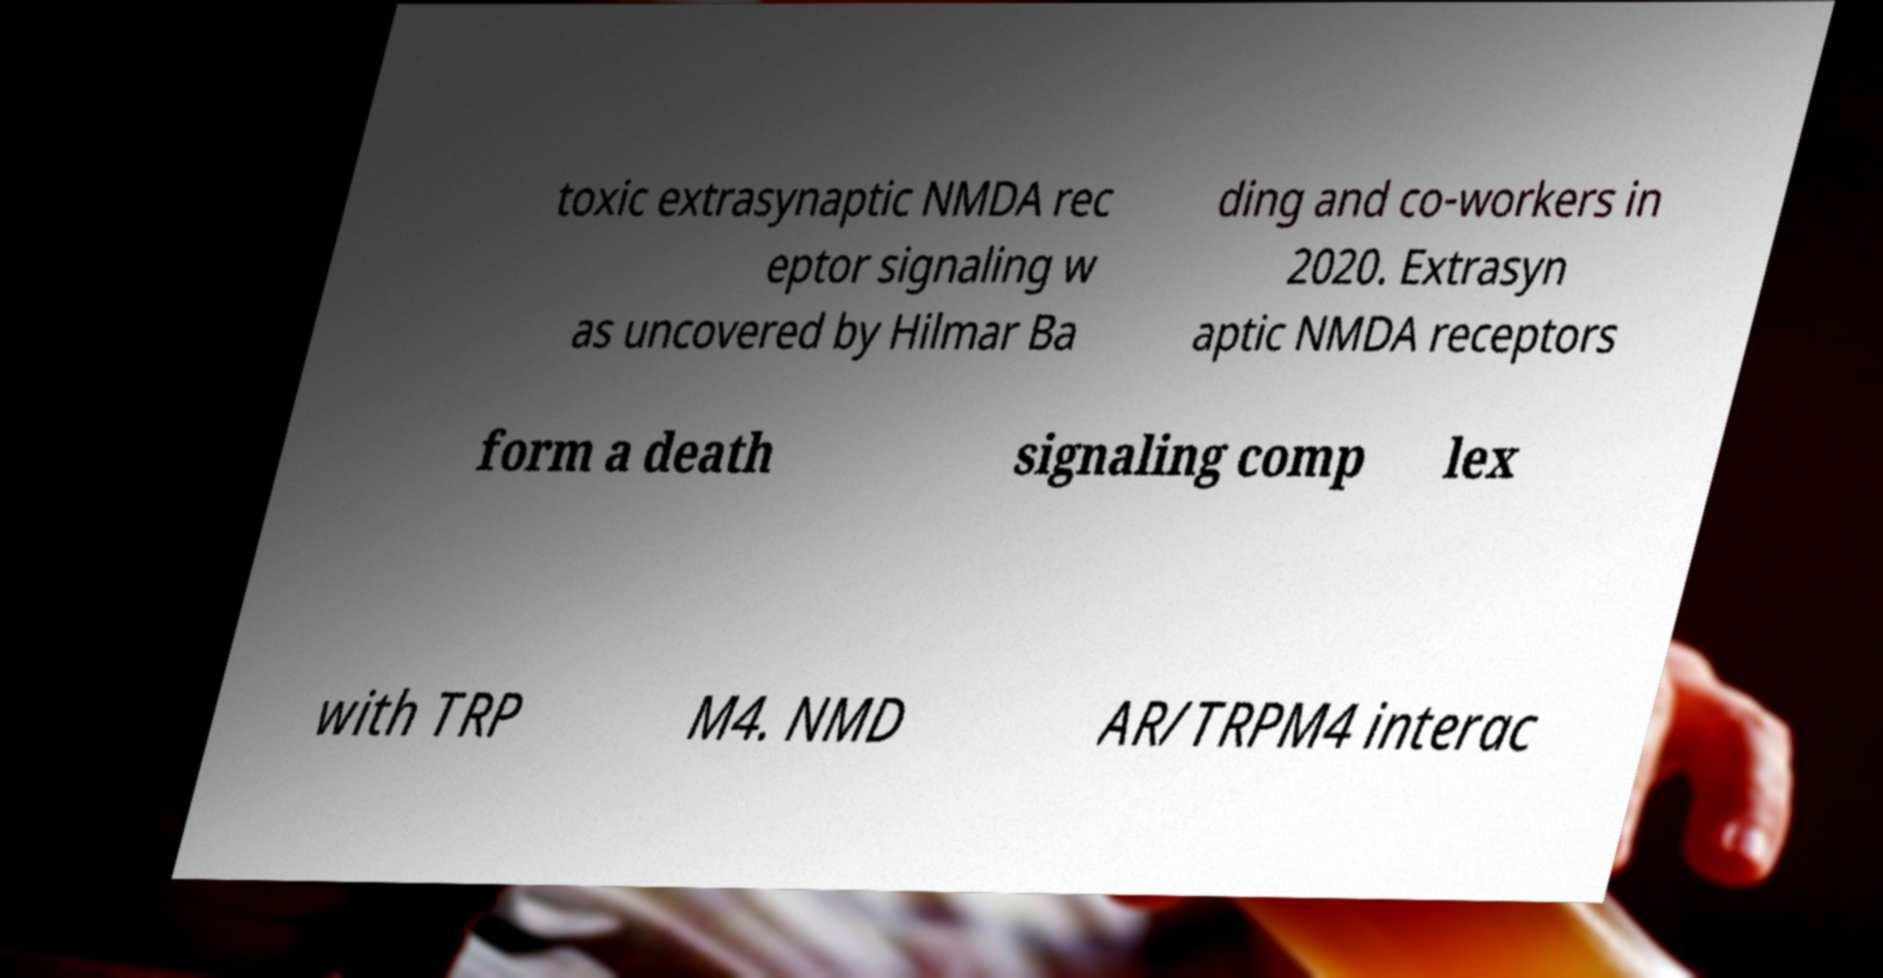Could you assist in decoding the text presented in this image and type it out clearly? toxic extrasynaptic NMDA rec eptor signaling w as uncovered by Hilmar Ba ding and co-workers in 2020. Extrasyn aptic NMDA receptors form a death signaling comp lex with TRP M4. NMD AR/TRPM4 interac 